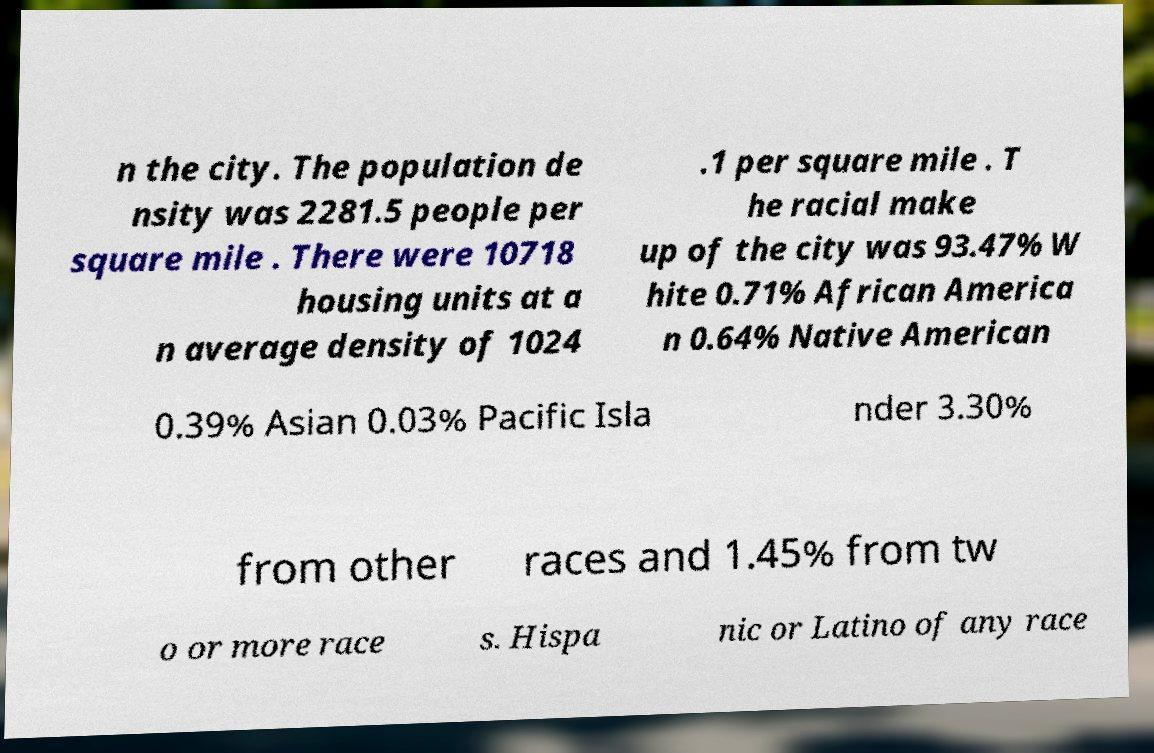Can you read and provide the text displayed in the image?This photo seems to have some interesting text. Can you extract and type it out for me? n the city. The population de nsity was 2281.5 people per square mile . There were 10718 housing units at a n average density of 1024 .1 per square mile . T he racial make up of the city was 93.47% W hite 0.71% African America n 0.64% Native American 0.39% Asian 0.03% Pacific Isla nder 3.30% from other races and 1.45% from tw o or more race s. Hispa nic or Latino of any race 